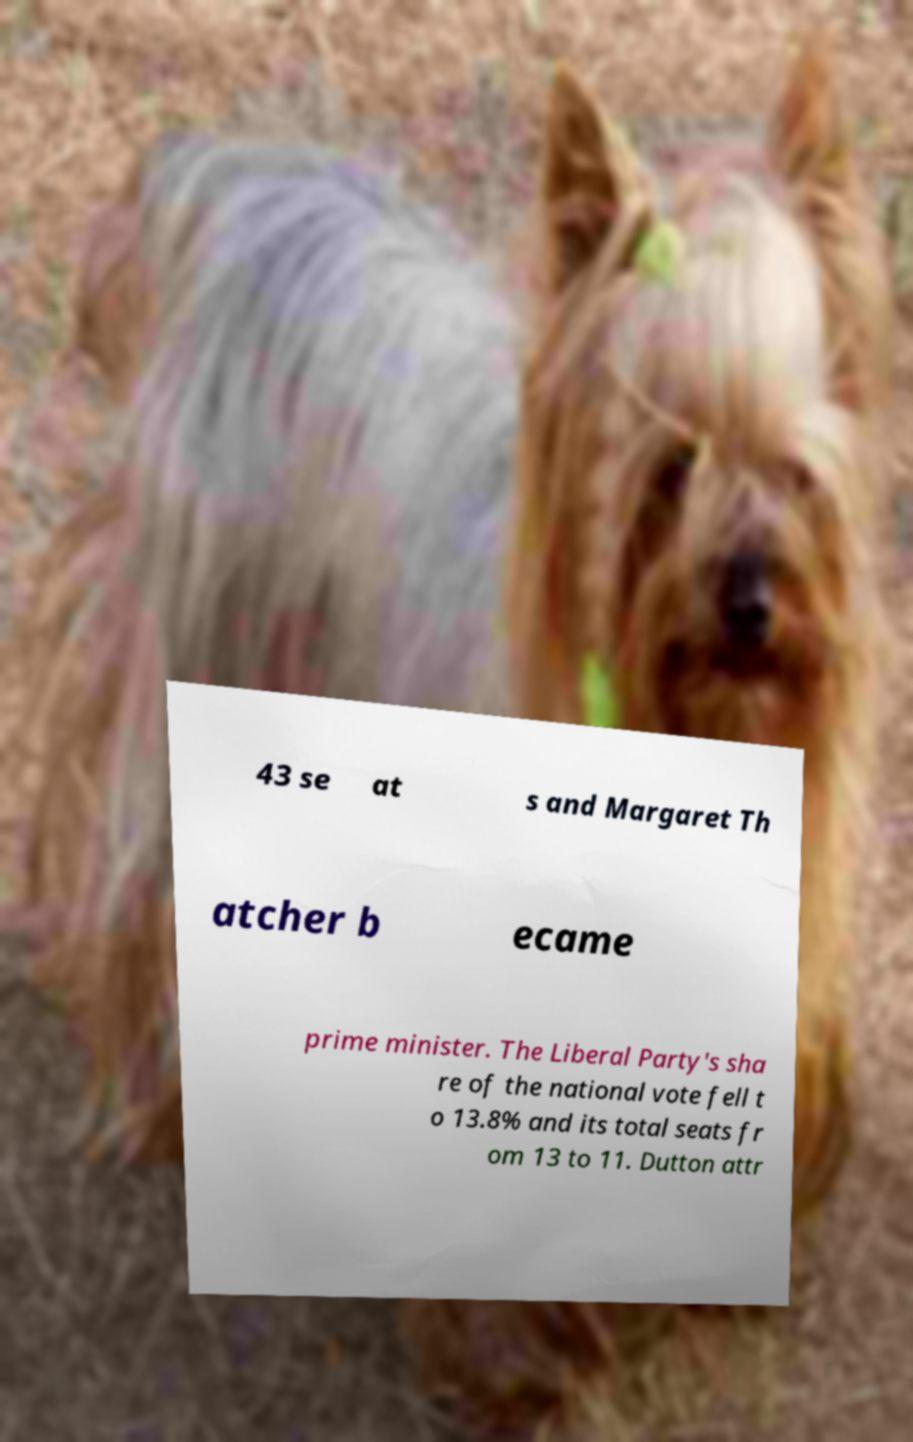There's text embedded in this image that I need extracted. Can you transcribe it verbatim? 43 se at s and Margaret Th atcher b ecame prime minister. The Liberal Party's sha re of the national vote fell t o 13.8% and its total seats fr om 13 to 11. Dutton attr 